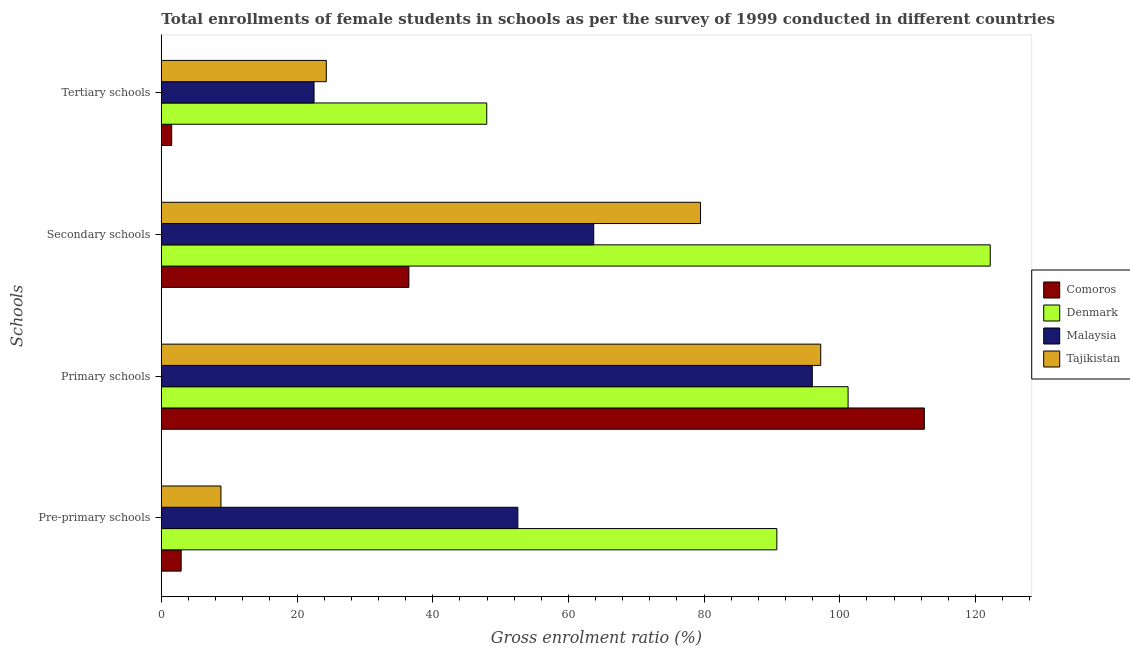How many different coloured bars are there?
Your response must be concise. 4. How many groups of bars are there?
Your answer should be very brief. 4. What is the label of the 1st group of bars from the top?
Your answer should be very brief. Tertiary schools. What is the gross enrolment ratio(female) in primary schools in Comoros?
Make the answer very short. 112.45. Across all countries, what is the maximum gross enrolment ratio(female) in tertiary schools?
Provide a short and direct response. 47.96. Across all countries, what is the minimum gross enrolment ratio(female) in primary schools?
Keep it short and to the point. 95.94. In which country was the gross enrolment ratio(female) in primary schools maximum?
Keep it short and to the point. Comoros. In which country was the gross enrolment ratio(female) in pre-primary schools minimum?
Your answer should be compact. Comoros. What is the total gross enrolment ratio(female) in tertiary schools in the graph?
Your answer should be very brief. 96.31. What is the difference between the gross enrolment ratio(female) in secondary schools in Comoros and that in Denmark?
Give a very brief answer. -85.68. What is the difference between the gross enrolment ratio(female) in secondary schools in Comoros and the gross enrolment ratio(female) in pre-primary schools in Denmark?
Give a very brief answer. -54.23. What is the average gross enrolment ratio(female) in secondary schools per country?
Offer a terse response. 75.46. What is the difference between the gross enrolment ratio(female) in tertiary schools and gross enrolment ratio(female) in pre-primary schools in Malaysia?
Your answer should be compact. -30.04. What is the ratio of the gross enrolment ratio(female) in tertiary schools in Malaysia to that in Tajikistan?
Give a very brief answer. 0.93. Is the difference between the gross enrolment ratio(female) in secondary schools in Denmark and Comoros greater than the difference between the gross enrolment ratio(female) in tertiary schools in Denmark and Comoros?
Your response must be concise. Yes. What is the difference between the highest and the second highest gross enrolment ratio(female) in pre-primary schools?
Offer a terse response. 38.17. What is the difference between the highest and the lowest gross enrolment ratio(female) in primary schools?
Make the answer very short. 16.51. What does the 1st bar from the top in Tertiary schools represents?
Your answer should be compact. Tajikistan. What does the 2nd bar from the bottom in Primary schools represents?
Provide a succinct answer. Denmark. How many bars are there?
Your response must be concise. 16. How many countries are there in the graph?
Give a very brief answer. 4. Are the values on the major ticks of X-axis written in scientific E-notation?
Offer a very short reply. No. Does the graph contain any zero values?
Provide a succinct answer. No. Where does the legend appear in the graph?
Give a very brief answer. Center right. How many legend labels are there?
Your answer should be very brief. 4. How are the legend labels stacked?
Keep it short and to the point. Vertical. What is the title of the graph?
Offer a very short reply. Total enrollments of female students in schools as per the survey of 1999 conducted in different countries. Does "Malaysia" appear as one of the legend labels in the graph?
Make the answer very short. Yes. What is the label or title of the X-axis?
Your answer should be compact. Gross enrolment ratio (%). What is the label or title of the Y-axis?
Provide a succinct answer. Schools. What is the Gross enrolment ratio (%) in Comoros in Pre-primary schools?
Give a very brief answer. 2.92. What is the Gross enrolment ratio (%) of Denmark in Pre-primary schools?
Keep it short and to the point. 90.72. What is the Gross enrolment ratio (%) in Malaysia in Pre-primary schools?
Your answer should be compact. 52.55. What is the Gross enrolment ratio (%) of Tajikistan in Pre-primary schools?
Offer a terse response. 8.79. What is the Gross enrolment ratio (%) of Comoros in Primary schools?
Offer a very short reply. 112.45. What is the Gross enrolment ratio (%) in Denmark in Primary schools?
Offer a terse response. 101.22. What is the Gross enrolment ratio (%) in Malaysia in Primary schools?
Make the answer very short. 95.94. What is the Gross enrolment ratio (%) in Tajikistan in Primary schools?
Offer a terse response. 97.18. What is the Gross enrolment ratio (%) of Comoros in Secondary schools?
Your answer should be compact. 36.49. What is the Gross enrolment ratio (%) of Denmark in Secondary schools?
Your answer should be compact. 122.17. What is the Gross enrolment ratio (%) of Malaysia in Secondary schools?
Make the answer very short. 63.73. What is the Gross enrolment ratio (%) in Tajikistan in Secondary schools?
Provide a short and direct response. 79.47. What is the Gross enrolment ratio (%) of Comoros in Tertiary schools?
Provide a succinct answer. 1.53. What is the Gross enrolment ratio (%) of Denmark in Tertiary schools?
Offer a very short reply. 47.96. What is the Gross enrolment ratio (%) of Malaysia in Tertiary schools?
Provide a short and direct response. 22.51. What is the Gross enrolment ratio (%) in Tajikistan in Tertiary schools?
Provide a succinct answer. 24.31. Across all Schools, what is the maximum Gross enrolment ratio (%) of Comoros?
Offer a terse response. 112.45. Across all Schools, what is the maximum Gross enrolment ratio (%) of Denmark?
Offer a terse response. 122.17. Across all Schools, what is the maximum Gross enrolment ratio (%) in Malaysia?
Ensure brevity in your answer.  95.94. Across all Schools, what is the maximum Gross enrolment ratio (%) in Tajikistan?
Your answer should be compact. 97.18. Across all Schools, what is the minimum Gross enrolment ratio (%) of Comoros?
Offer a very short reply. 1.53. Across all Schools, what is the minimum Gross enrolment ratio (%) in Denmark?
Offer a very short reply. 47.96. Across all Schools, what is the minimum Gross enrolment ratio (%) in Malaysia?
Offer a terse response. 22.51. Across all Schools, what is the minimum Gross enrolment ratio (%) in Tajikistan?
Your answer should be compact. 8.79. What is the total Gross enrolment ratio (%) of Comoros in the graph?
Your answer should be compact. 153.39. What is the total Gross enrolment ratio (%) of Denmark in the graph?
Your response must be concise. 362.06. What is the total Gross enrolment ratio (%) of Malaysia in the graph?
Your answer should be compact. 234.73. What is the total Gross enrolment ratio (%) of Tajikistan in the graph?
Your answer should be compact. 209.75. What is the difference between the Gross enrolment ratio (%) of Comoros in Pre-primary schools and that in Primary schools?
Your response must be concise. -109.53. What is the difference between the Gross enrolment ratio (%) in Denmark in Pre-primary schools and that in Primary schools?
Your answer should be very brief. -10.5. What is the difference between the Gross enrolment ratio (%) in Malaysia in Pre-primary schools and that in Primary schools?
Your response must be concise. -43.4. What is the difference between the Gross enrolment ratio (%) of Tajikistan in Pre-primary schools and that in Primary schools?
Your response must be concise. -88.39. What is the difference between the Gross enrolment ratio (%) in Comoros in Pre-primary schools and that in Secondary schools?
Ensure brevity in your answer.  -33.56. What is the difference between the Gross enrolment ratio (%) in Denmark in Pre-primary schools and that in Secondary schools?
Your answer should be compact. -31.45. What is the difference between the Gross enrolment ratio (%) of Malaysia in Pre-primary schools and that in Secondary schools?
Make the answer very short. -11.18. What is the difference between the Gross enrolment ratio (%) in Tajikistan in Pre-primary schools and that in Secondary schools?
Keep it short and to the point. -70.68. What is the difference between the Gross enrolment ratio (%) of Comoros in Pre-primary schools and that in Tertiary schools?
Ensure brevity in your answer.  1.4. What is the difference between the Gross enrolment ratio (%) in Denmark in Pre-primary schools and that in Tertiary schools?
Keep it short and to the point. 42.75. What is the difference between the Gross enrolment ratio (%) in Malaysia in Pre-primary schools and that in Tertiary schools?
Your answer should be very brief. 30.04. What is the difference between the Gross enrolment ratio (%) in Tajikistan in Pre-primary schools and that in Tertiary schools?
Offer a very short reply. -15.52. What is the difference between the Gross enrolment ratio (%) of Comoros in Primary schools and that in Secondary schools?
Provide a short and direct response. 75.97. What is the difference between the Gross enrolment ratio (%) in Denmark in Primary schools and that in Secondary schools?
Keep it short and to the point. -20.95. What is the difference between the Gross enrolment ratio (%) in Malaysia in Primary schools and that in Secondary schools?
Keep it short and to the point. 32.22. What is the difference between the Gross enrolment ratio (%) of Tajikistan in Primary schools and that in Secondary schools?
Your answer should be compact. 17.72. What is the difference between the Gross enrolment ratio (%) in Comoros in Primary schools and that in Tertiary schools?
Make the answer very short. 110.93. What is the difference between the Gross enrolment ratio (%) in Denmark in Primary schools and that in Tertiary schools?
Your answer should be compact. 53.25. What is the difference between the Gross enrolment ratio (%) in Malaysia in Primary schools and that in Tertiary schools?
Your answer should be compact. 73.43. What is the difference between the Gross enrolment ratio (%) in Tajikistan in Primary schools and that in Tertiary schools?
Your response must be concise. 72.87. What is the difference between the Gross enrolment ratio (%) in Comoros in Secondary schools and that in Tertiary schools?
Offer a terse response. 34.96. What is the difference between the Gross enrolment ratio (%) in Denmark in Secondary schools and that in Tertiary schools?
Give a very brief answer. 74.2. What is the difference between the Gross enrolment ratio (%) of Malaysia in Secondary schools and that in Tertiary schools?
Provide a succinct answer. 41.22. What is the difference between the Gross enrolment ratio (%) of Tajikistan in Secondary schools and that in Tertiary schools?
Provide a succinct answer. 55.15. What is the difference between the Gross enrolment ratio (%) of Comoros in Pre-primary schools and the Gross enrolment ratio (%) of Denmark in Primary schools?
Your answer should be very brief. -98.29. What is the difference between the Gross enrolment ratio (%) of Comoros in Pre-primary schools and the Gross enrolment ratio (%) of Malaysia in Primary schools?
Your response must be concise. -93.02. What is the difference between the Gross enrolment ratio (%) of Comoros in Pre-primary schools and the Gross enrolment ratio (%) of Tajikistan in Primary schools?
Your answer should be very brief. -94.26. What is the difference between the Gross enrolment ratio (%) of Denmark in Pre-primary schools and the Gross enrolment ratio (%) of Malaysia in Primary schools?
Your answer should be compact. -5.23. What is the difference between the Gross enrolment ratio (%) in Denmark in Pre-primary schools and the Gross enrolment ratio (%) in Tajikistan in Primary schools?
Your response must be concise. -6.47. What is the difference between the Gross enrolment ratio (%) of Malaysia in Pre-primary schools and the Gross enrolment ratio (%) of Tajikistan in Primary schools?
Offer a very short reply. -44.64. What is the difference between the Gross enrolment ratio (%) of Comoros in Pre-primary schools and the Gross enrolment ratio (%) of Denmark in Secondary schools?
Ensure brevity in your answer.  -119.24. What is the difference between the Gross enrolment ratio (%) of Comoros in Pre-primary schools and the Gross enrolment ratio (%) of Malaysia in Secondary schools?
Your answer should be very brief. -60.8. What is the difference between the Gross enrolment ratio (%) of Comoros in Pre-primary schools and the Gross enrolment ratio (%) of Tajikistan in Secondary schools?
Ensure brevity in your answer.  -76.54. What is the difference between the Gross enrolment ratio (%) in Denmark in Pre-primary schools and the Gross enrolment ratio (%) in Malaysia in Secondary schools?
Provide a short and direct response. 26.99. What is the difference between the Gross enrolment ratio (%) in Denmark in Pre-primary schools and the Gross enrolment ratio (%) in Tajikistan in Secondary schools?
Your answer should be compact. 11.25. What is the difference between the Gross enrolment ratio (%) in Malaysia in Pre-primary schools and the Gross enrolment ratio (%) in Tajikistan in Secondary schools?
Keep it short and to the point. -26.92. What is the difference between the Gross enrolment ratio (%) in Comoros in Pre-primary schools and the Gross enrolment ratio (%) in Denmark in Tertiary schools?
Make the answer very short. -45.04. What is the difference between the Gross enrolment ratio (%) in Comoros in Pre-primary schools and the Gross enrolment ratio (%) in Malaysia in Tertiary schools?
Your answer should be compact. -19.59. What is the difference between the Gross enrolment ratio (%) of Comoros in Pre-primary schools and the Gross enrolment ratio (%) of Tajikistan in Tertiary schools?
Your answer should be compact. -21.39. What is the difference between the Gross enrolment ratio (%) in Denmark in Pre-primary schools and the Gross enrolment ratio (%) in Malaysia in Tertiary schools?
Make the answer very short. 68.21. What is the difference between the Gross enrolment ratio (%) of Denmark in Pre-primary schools and the Gross enrolment ratio (%) of Tajikistan in Tertiary schools?
Your response must be concise. 66.4. What is the difference between the Gross enrolment ratio (%) in Malaysia in Pre-primary schools and the Gross enrolment ratio (%) in Tajikistan in Tertiary schools?
Your answer should be compact. 28.23. What is the difference between the Gross enrolment ratio (%) in Comoros in Primary schools and the Gross enrolment ratio (%) in Denmark in Secondary schools?
Ensure brevity in your answer.  -9.71. What is the difference between the Gross enrolment ratio (%) of Comoros in Primary schools and the Gross enrolment ratio (%) of Malaysia in Secondary schools?
Offer a terse response. 48.73. What is the difference between the Gross enrolment ratio (%) of Comoros in Primary schools and the Gross enrolment ratio (%) of Tajikistan in Secondary schools?
Your response must be concise. 32.99. What is the difference between the Gross enrolment ratio (%) in Denmark in Primary schools and the Gross enrolment ratio (%) in Malaysia in Secondary schools?
Provide a short and direct response. 37.49. What is the difference between the Gross enrolment ratio (%) of Denmark in Primary schools and the Gross enrolment ratio (%) of Tajikistan in Secondary schools?
Provide a short and direct response. 21.75. What is the difference between the Gross enrolment ratio (%) in Malaysia in Primary schools and the Gross enrolment ratio (%) in Tajikistan in Secondary schools?
Keep it short and to the point. 16.48. What is the difference between the Gross enrolment ratio (%) in Comoros in Primary schools and the Gross enrolment ratio (%) in Denmark in Tertiary schools?
Keep it short and to the point. 64.49. What is the difference between the Gross enrolment ratio (%) in Comoros in Primary schools and the Gross enrolment ratio (%) in Malaysia in Tertiary schools?
Keep it short and to the point. 89.94. What is the difference between the Gross enrolment ratio (%) of Comoros in Primary schools and the Gross enrolment ratio (%) of Tajikistan in Tertiary schools?
Provide a short and direct response. 88.14. What is the difference between the Gross enrolment ratio (%) of Denmark in Primary schools and the Gross enrolment ratio (%) of Malaysia in Tertiary schools?
Ensure brevity in your answer.  78.71. What is the difference between the Gross enrolment ratio (%) of Denmark in Primary schools and the Gross enrolment ratio (%) of Tajikistan in Tertiary schools?
Offer a very short reply. 76.9. What is the difference between the Gross enrolment ratio (%) in Malaysia in Primary schools and the Gross enrolment ratio (%) in Tajikistan in Tertiary schools?
Your response must be concise. 71.63. What is the difference between the Gross enrolment ratio (%) of Comoros in Secondary schools and the Gross enrolment ratio (%) of Denmark in Tertiary schools?
Keep it short and to the point. -11.48. What is the difference between the Gross enrolment ratio (%) in Comoros in Secondary schools and the Gross enrolment ratio (%) in Malaysia in Tertiary schools?
Offer a terse response. 13.98. What is the difference between the Gross enrolment ratio (%) in Comoros in Secondary schools and the Gross enrolment ratio (%) in Tajikistan in Tertiary schools?
Provide a succinct answer. 12.17. What is the difference between the Gross enrolment ratio (%) in Denmark in Secondary schools and the Gross enrolment ratio (%) in Malaysia in Tertiary schools?
Keep it short and to the point. 99.66. What is the difference between the Gross enrolment ratio (%) in Denmark in Secondary schools and the Gross enrolment ratio (%) in Tajikistan in Tertiary schools?
Keep it short and to the point. 97.85. What is the difference between the Gross enrolment ratio (%) of Malaysia in Secondary schools and the Gross enrolment ratio (%) of Tajikistan in Tertiary schools?
Offer a terse response. 39.41. What is the average Gross enrolment ratio (%) in Comoros per Schools?
Offer a terse response. 38.35. What is the average Gross enrolment ratio (%) of Denmark per Schools?
Give a very brief answer. 90.52. What is the average Gross enrolment ratio (%) of Malaysia per Schools?
Give a very brief answer. 58.68. What is the average Gross enrolment ratio (%) in Tajikistan per Schools?
Offer a very short reply. 52.44. What is the difference between the Gross enrolment ratio (%) of Comoros and Gross enrolment ratio (%) of Denmark in Pre-primary schools?
Your response must be concise. -87.79. What is the difference between the Gross enrolment ratio (%) in Comoros and Gross enrolment ratio (%) in Malaysia in Pre-primary schools?
Your response must be concise. -49.62. What is the difference between the Gross enrolment ratio (%) in Comoros and Gross enrolment ratio (%) in Tajikistan in Pre-primary schools?
Make the answer very short. -5.86. What is the difference between the Gross enrolment ratio (%) of Denmark and Gross enrolment ratio (%) of Malaysia in Pre-primary schools?
Your answer should be compact. 38.17. What is the difference between the Gross enrolment ratio (%) of Denmark and Gross enrolment ratio (%) of Tajikistan in Pre-primary schools?
Your response must be concise. 81.93. What is the difference between the Gross enrolment ratio (%) in Malaysia and Gross enrolment ratio (%) in Tajikistan in Pre-primary schools?
Ensure brevity in your answer.  43.76. What is the difference between the Gross enrolment ratio (%) in Comoros and Gross enrolment ratio (%) in Denmark in Primary schools?
Ensure brevity in your answer.  11.24. What is the difference between the Gross enrolment ratio (%) of Comoros and Gross enrolment ratio (%) of Malaysia in Primary schools?
Your response must be concise. 16.51. What is the difference between the Gross enrolment ratio (%) in Comoros and Gross enrolment ratio (%) in Tajikistan in Primary schools?
Offer a very short reply. 15.27. What is the difference between the Gross enrolment ratio (%) of Denmark and Gross enrolment ratio (%) of Malaysia in Primary schools?
Provide a succinct answer. 5.27. What is the difference between the Gross enrolment ratio (%) of Denmark and Gross enrolment ratio (%) of Tajikistan in Primary schools?
Provide a short and direct response. 4.03. What is the difference between the Gross enrolment ratio (%) in Malaysia and Gross enrolment ratio (%) in Tajikistan in Primary schools?
Keep it short and to the point. -1.24. What is the difference between the Gross enrolment ratio (%) in Comoros and Gross enrolment ratio (%) in Denmark in Secondary schools?
Provide a short and direct response. -85.68. What is the difference between the Gross enrolment ratio (%) of Comoros and Gross enrolment ratio (%) of Malaysia in Secondary schools?
Offer a very short reply. -27.24. What is the difference between the Gross enrolment ratio (%) of Comoros and Gross enrolment ratio (%) of Tajikistan in Secondary schools?
Make the answer very short. -42.98. What is the difference between the Gross enrolment ratio (%) in Denmark and Gross enrolment ratio (%) in Malaysia in Secondary schools?
Offer a terse response. 58.44. What is the difference between the Gross enrolment ratio (%) in Denmark and Gross enrolment ratio (%) in Tajikistan in Secondary schools?
Your answer should be very brief. 42.7. What is the difference between the Gross enrolment ratio (%) in Malaysia and Gross enrolment ratio (%) in Tajikistan in Secondary schools?
Your answer should be compact. -15.74. What is the difference between the Gross enrolment ratio (%) of Comoros and Gross enrolment ratio (%) of Denmark in Tertiary schools?
Ensure brevity in your answer.  -46.44. What is the difference between the Gross enrolment ratio (%) of Comoros and Gross enrolment ratio (%) of Malaysia in Tertiary schools?
Ensure brevity in your answer.  -20.98. What is the difference between the Gross enrolment ratio (%) in Comoros and Gross enrolment ratio (%) in Tajikistan in Tertiary schools?
Provide a succinct answer. -22.79. What is the difference between the Gross enrolment ratio (%) in Denmark and Gross enrolment ratio (%) in Malaysia in Tertiary schools?
Your response must be concise. 25.45. What is the difference between the Gross enrolment ratio (%) of Denmark and Gross enrolment ratio (%) of Tajikistan in Tertiary schools?
Your response must be concise. 23.65. What is the difference between the Gross enrolment ratio (%) in Malaysia and Gross enrolment ratio (%) in Tajikistan in Tertiary schools?
Keep it short and to the point. -1.8. What is the ratio of the Gross enrolment ratio (%) of Comoros in Pre-primary schools to that in Primary schools?
Keep it short and to the point. 0.03. What is the ratio of the Gross enrolment ratio (%) in Denmark in Pre-primary schools to that in Primary schools?
Keep it short and to the point. 0.9. What is the ratio of the Gross enrolment ratio (%) in Malaysia in Pre-primary schools to that in Primary schools?
Give a very brief answer. 0.55. What is the ratio of the Gross enrolment ratio (%) of Tajikistan in Pre-primary schools to that in Primary schools?
Your answer should be very brief. 0.09. What is the ratio of the Gross enrolment ratio (%) in Comoros in Pre-primary schools to that in Secondary schools?
Ensure brevity in your answer.  0.08. What is the ratio of the Gross enrolment ratio (%) in Denmark in Pre-primary schools to that in Secondary schools?
Provide a succinct answer. 0.74. What is the ratio of the Gross enrolment ratio (%) in Malaysia in Pre-primary schools to that in Secondary schools?
Ensure brevity in your answer.  0.82. What is the ratio of the Gross enrolment ratio (%) of Tajikistan in Pre-primary schools to that in Secondary schools?
Keep it short and to the point. 0.11. What is the ratio of the Gross enrolment ratio (%) in Comoros in Pre-primary schools to that in Tertiary schools?
Give a very brief answer. 1.91. What is the ratio of the Gross enrolment ratio (%) in Denmark in Pre-primary schools to that in Tertiary schools?
Provide a short and direct response. 1.89. What is the ratio of the Gross enrolment ratio (%) of Malaysia in Pre-primary schools to that in Tertiary schools?
Your response must be concise. 2.33. What is the ratio of the Gross enrolment ratio (%) of Tajikistan in Pre-primary schools to that in Tertiary schools?
Make the answer very short. 0.36. What is the ratio of the Gross enrolment ratio (%) of Comoros in Primary schools to that in Secondary schools?
Make the answer very short. 3.08. What is the ratio of the Gross enrolment ratio (%) in Denmark in Primary schools to that in Secondary schools?
Keep it short and to the point. 0.83. What is the ratio of the Gross enrolment ratio (%) of Malaysia in Primary schools to that in Secondary schools?
Offer a terse response. 1.51. What is the ratio of the Gross enrolment ratio (%) of Tajikistan in Primary schools to that in Secondary schools?
Provide a succinct answer. 1.22. What is the ratio of the Gross enrolment ratio (%) of Comoros in Primary schools to that in Tertiary schools?
Ensure brevity in your answer.  73.61. What is the ratio of the Gross enrolment ratio (%) in Denmark in Primary schools to that in Tertiary schools?
Provide a succinct answer. 2.11. What is the ratio of the Gross enrolment ratio (%) of Malaysia in Primary schools to that in Tertiary schools?
Make the answer very short. 4.26. What is the ratio of the Gross enrolment ratio (%) of Tajikistan in Primary schools to that in Tertiary schools?
Keep it short and to the point. 4. What is the ratio of the Gross enrolment ratio (%) in Comoros in Secondary schools to that in Tertiary schools?
Your answer should be compact. 23.88. What is the ratio of the Gross enrolment ratio (%) in Denmark in Secondary schools to that in Tertiary schools?
Offer a very short reply. 2.55. What is the ratio of the Gross enrolment ratio (%) of Malaysia in Secondary schools to that in Tertiary schools?
Keep it short and to the point. 2.83. What is the ratio of the Gross enrolment ratio (%) of Tajikistan in Secondary schools to that in Tertiary schools?
Give a very brief answer. 3.27. What is the difference between the highest and the second highest Gross enrolment ratio (%) in Comoros?
Make the answer very short. 75.97. What is the difference between the highest and the second highest Gross enrolment ratio (%) in Denmark?
Your answer should be very brief. 20.95. What is the difference between the highest and the second highest Gross enrolment ratio (%) of Malaysia?
Your answer should be compact. 32.22. What is the difference between the highest and the second highest Gross enrolment ratio (%) in Tajikistan?
Keep it short and to the point. 17.72. What is the difference between the highest and the lowest Gross enrolment ratio (%) of Comoros?
Offer a terse response. 110.93. What is the difference between the highest and the lowest Gross enrolment ratio (%) of Denmark?
Keep it short and to the point. 74.2. What is the difference between the highest and the lowest Gross enrolment ratio (%) in Malaysia?
Give a very brief answer. 73.43. What is the difference between the highest and the lowest Gross enrolment ratio (%) of Tajikistan?
Provide a short and direct response. 88.39. 